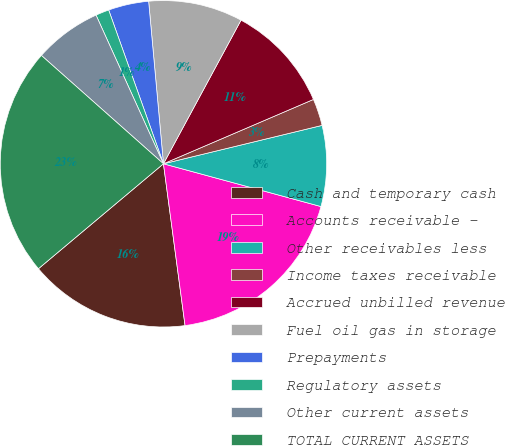<chart> <loc_0><loc_0><loc_500><loc_500><pie_chart><fcel>Cash and temporary cash<fcel>Accounts receivable -<fcel>Other receivables less<fcel>Income taxes receivable<fcel>Accrued unbilled revenue<fcel>Fuel oil gas in storage<fcel>Prepayments<fcel>Regulatory assets<fcel>Other current assets<fcel>TOTAL CURRENT ASSETS<nl><fcel>16.0%<fcel>18.67%<fcel>8.0%<fcel>2.67%<fcel>10.67%<fcel>9.33%<fcel>4.0%<fcel>1.33%<fcel>6.67%<fcel>22.67%<nl></chart> 